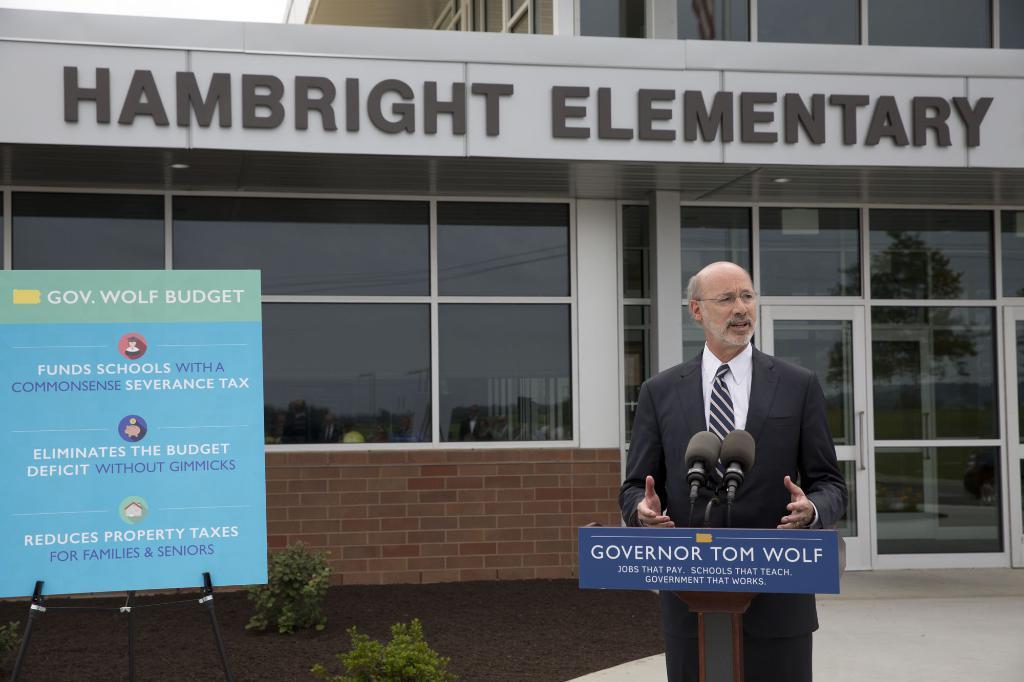How would you summarize this image in a sentence or two? In front of the picture, we see a man in the black blazer is standing. He is wearing the spectacles. In front of him, we see a podium on which the microphones are placed and he is talking on the microphone. On the left side, we see the shrubs, stand and a board in blue and green color with some text written on it. In the background, we see a building in white and brown color. It has the glass doors and the glass windows. On top of the building, it is written as "HAMBRIGHT ELEMENTARY". 